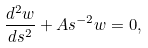<formula> <loc_0><loc_0><loc_500><loc_500>\frac { d ^ { 2 } w } { d s ^ { 2 } } + A s ^ { - 2 } w = 0 ,</formula> 